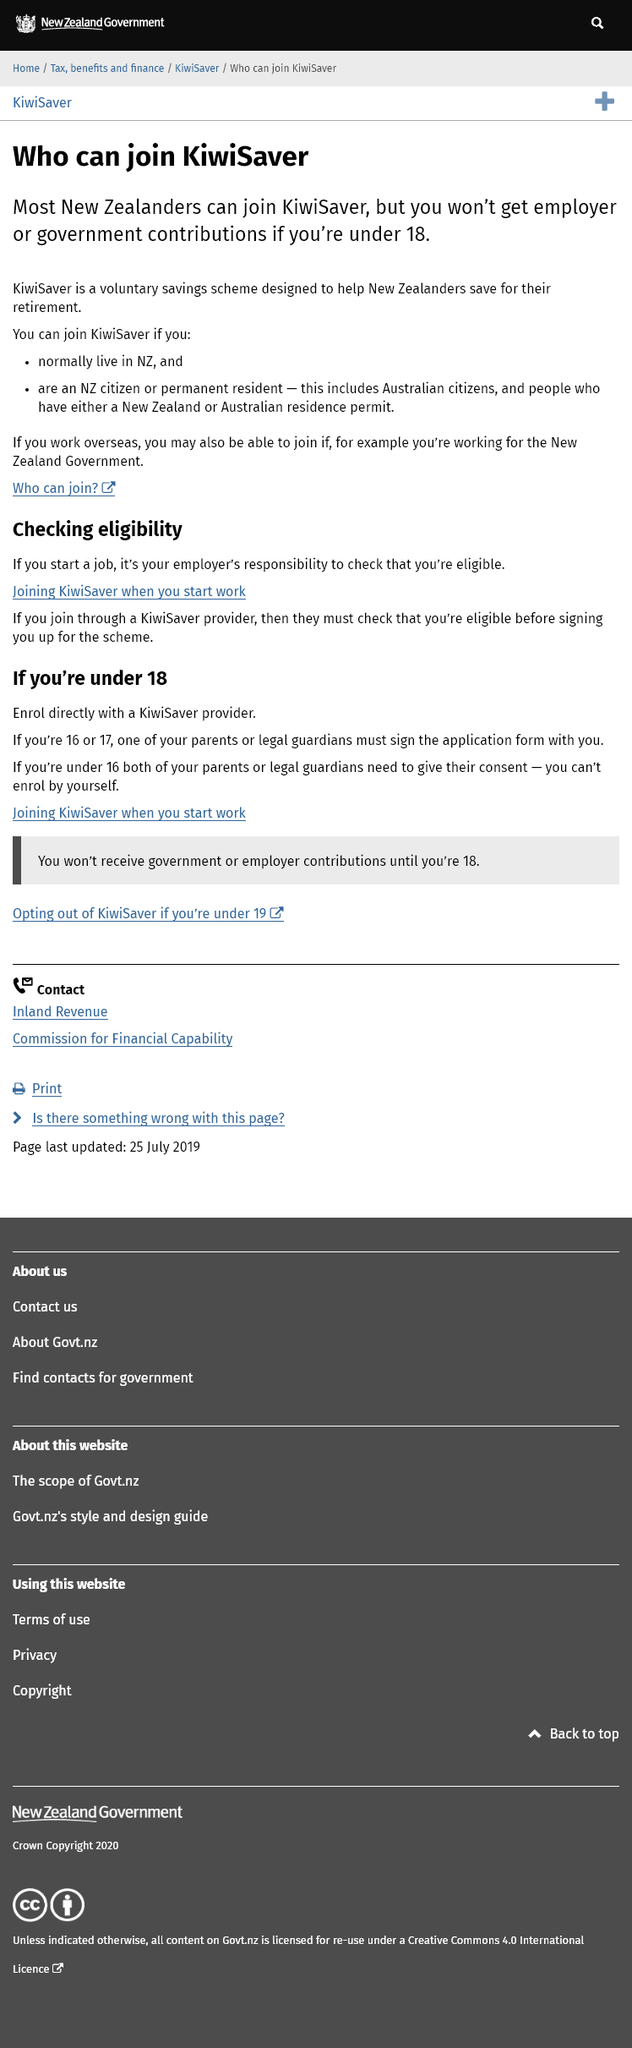List a handful of essential elements in this visual. To begin receiving employer or government contributions to a KiwiSaver account, a person must be at least 18 years old. It is the responsibility of an individual's employer to determine their eligibility for KiwiSaver when they are employed. You must be at least 18 years old to enroll in KiwiSaver on your own. If you are under 18, you will need the consent of one or both of your parents or legal guardians in order to enroll. 